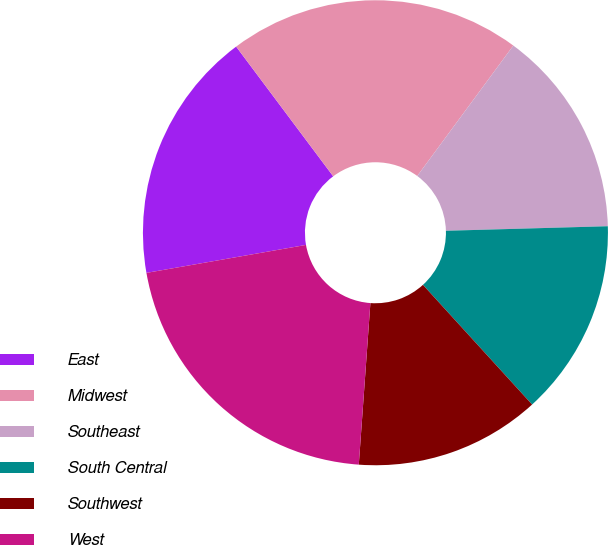Convert chart to OTSL. <chart><loc_0><loc_0><loc_500><loc_500><pie_chart><fcel>East<fcel>Midwest<fcel>Southeast<fcel>South Central<fcel>Southwest<fcel>West<nl><fcel>17.54%<fcel>20.33%<fcel>14.45%<fcel>13.68%<fcel>12.91%<fcel>21.1%<nl></chart> 